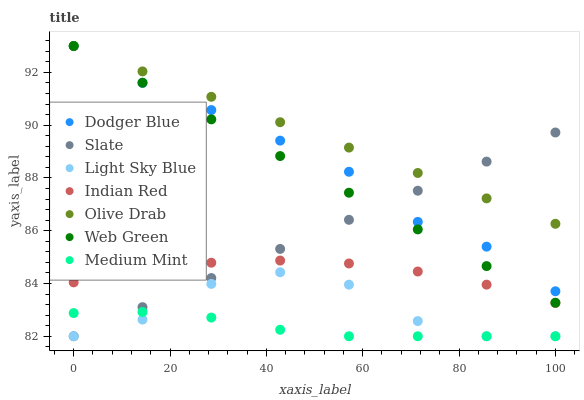Does Medium Mint have the minimum area under the curve?
Answer yes or no. Yes. Does Olive Drab have the maximum area under the curve?
Answer yes or no. Yes. Does Slate have the minimum area under the curve?
Answer yes or no. No. Does Slate have the maximum area under the curve?
Answer yes or no. No. Is Slate the smoothest?
Answer yes or no. Yes. Is Light Sky Blue the roughest?
Answer yes or no. Yes. Is Web Green the smoothest?
Answer yes or no. No. Is Web Green the roughest?
Answer yes or no. No. Does Medium Mint have the lowest value?
Answer yes or no. Yes. Does Web Green have the lowest value?
Answer yes or no. No. Does Olive Drab have the highest value?
Answer yes or no. Yes. Does Slate have the highest value?
Answer yes or no. No. Is Indian Red less than Web Green?
Answer yes or no. Yes. Is Web Green greater than Indian Red?
Answer yes or no. Yes. Does Slate intersect Indian Red?
Answer yes or no. Yes. Is Slate less than Indian Red?
Answer yes or no. No. Is Slate greater than Indian Red?
Answer yes or no. No. Does Indian Red intersect Web Green?
Answer yes or no. No. 